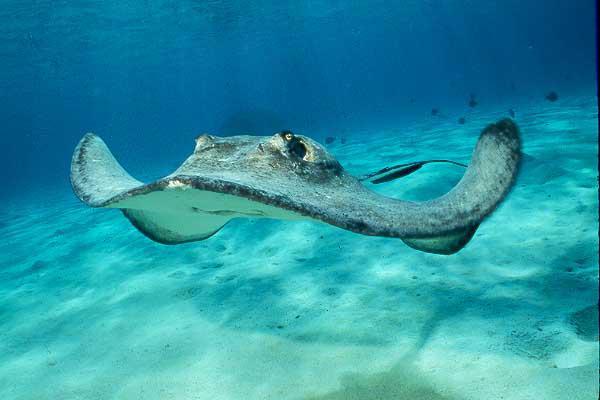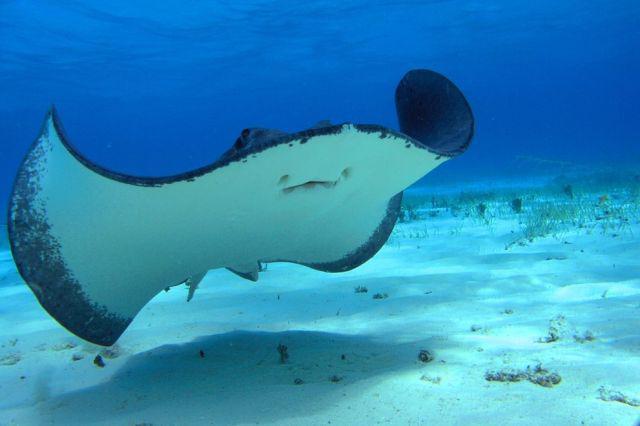The first image is the image on the left, the second image is the image on the right. Given the left and right images, does the statement "No image contains more than two stingray, and one image shows the underside of at least one stingray, while the other image shows the top of at least one stingray." hold true? Answer yes or no. Yes. The first image is the image on the left, the second image is the image on the right. Examine the images to the left and right. Is the description "The left and right image contains no more than three stingrays." accurate? Answer yes or no. Yes. 